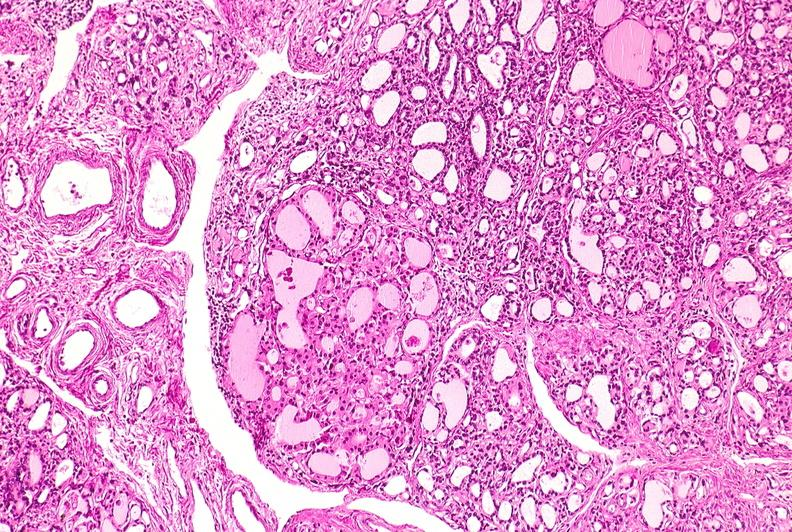does this image show thyroid, hashimoto 's?
Answer the question using a single word or phrase. Yes 